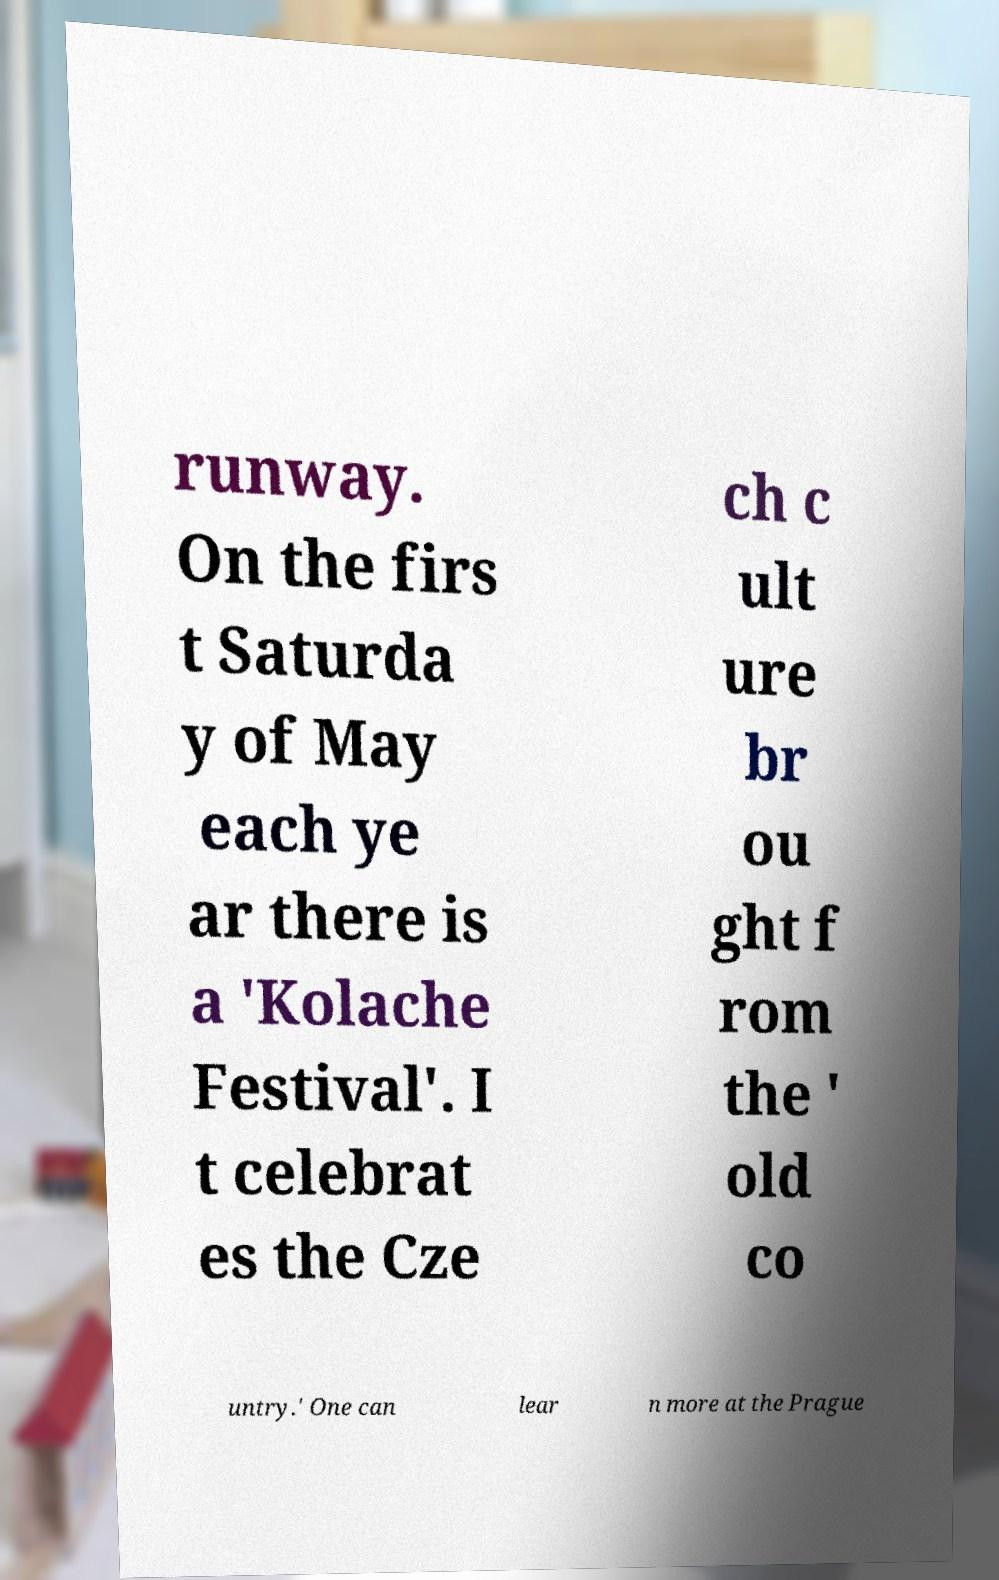What messages or text are displayed in this image? I need them in a readable, typed format. runway. On the firs t Saturda y of May each ye ar there is a 'Kolache Festival'. I t celebrat es the Cze ch c ult ure br ou ght f rom the ' old co untry.' One can lear n more at the Prague 